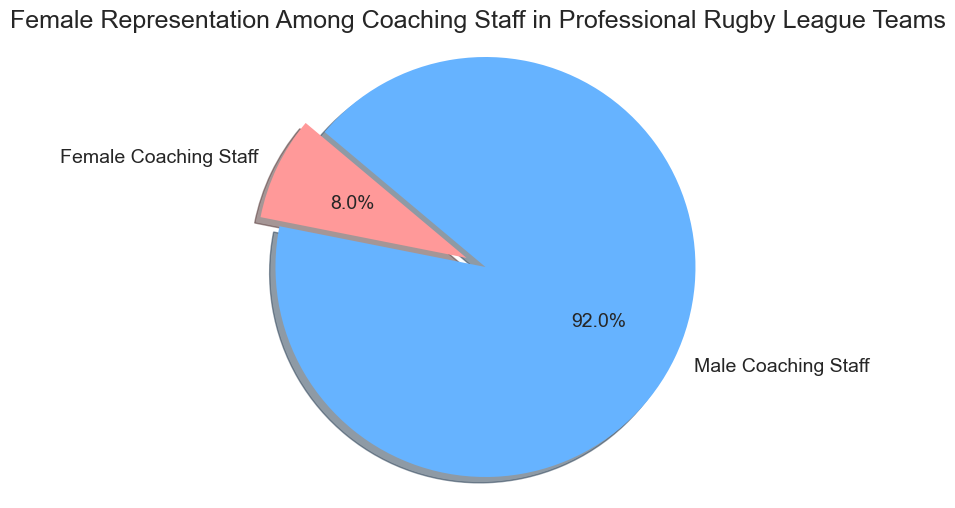what percentage of coaching staff are female? Look at the slice labeled "Female Coaching Staff" on the pie chart. The percentage is shown directly in the label.
Answer: 8.0% What is the ratio of male to female coaching staff? The pie chart shows 92% male and 8% female coaching staff. To find the ratio, divide the percentage of males by the percentage of females: 92/8.
Answer: 11.5 Which category has the largest representation? Compare the sizes of the slices. The "Male Coaching Staff" slice is visually larger.
Answer: Male Coaching Staff What is the total number of coaching staff? Sum the counts of both categories: 8 (Female Coaching Staff) + 92 (Male Coaching Staff).
Answer: 100 If 4 more female coaches were hired, what would be the new percentage of female coaching staff? New total number of coaching staff: 100 + 4 = 104. New count of female coaching staff: 8 + 4 = 12. The percentage of female coaching staff is (12/104) * 100.
Answer: 11.5% How many more male coaching staff are there than female? Subtract the count of female coaching staff from the count of male coaching staff: 92 - 8.
Answer: 84 What fraction of the coaching staff are male? Divide the count of male coaching staff by the total number of coaching staff: 92 / 100.
Answer: 0.92 What color represents the female coaching staff? Identify the color used for the "Female Coaching Staff" slice in the pie chart.
Answer: Red How much larger is the male coaching staff percentage compared to female? Subtract the percentage of female coaching staff from the percentage of male coaching staff: 92% - 8%.
Answer: 84% What is the combined percentage of male and female coaching staff? Add the percentages of male and female coaching staff: 92% + 8%.
Answer: 100% 